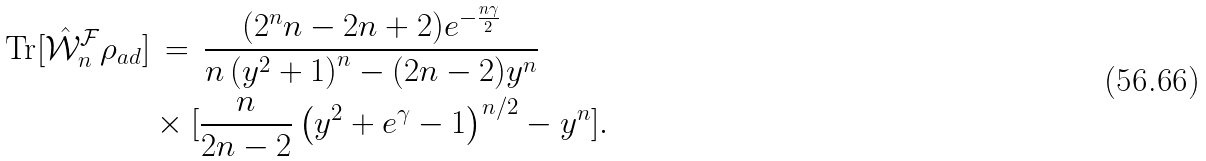Convert formula to latex. <formula><loc_0><loc_0><loc_500><loc_500>\text {Tr} [ { \hat { \mathcal { W } } ^ { \mathcal { F } } _ { n } \rho _ { a d } } ] & \, = \, \frac { ( 2 ^ { n } n - 2 n + 2 ) e ^ { - \frac { n \gamma } { 2 } } } { n \left ( y ^ { 2 } + 1 \right ) ^ { n } - ( 2 n - 2 ) y ^ { n } } \\ & \times [ \frac { n } { 2 n - 2 } \left ( y ^ { 2 } + e ^ { \gamma } - 1 \right ) ^ { n / 2 } - y ^ { n } ] .</formula> 